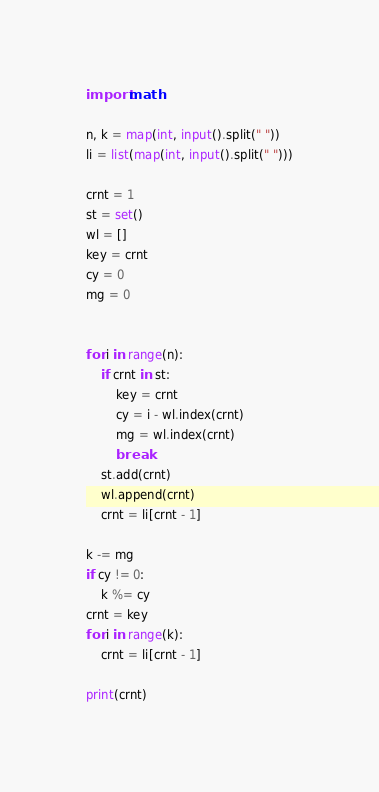Convert code to text. <code><loc_0><loc_0><loc_500><loc_500><_Python_>import math

n, k = map(int, input().split(" "))
li = list(map(int, input().split(" ")))

crnt = 1
st = set()
wl = []
key = crnt
cy = 0
mg = 0


for i in range(n):
    if crnt in st:
        key = crnt
        cy = i - wl.index(crnt)
        mg = wl.index(crnt)
        break
    st.add(crnt)
    wl.append(crnt)
    crnt = li[crnt - 1]

k -= mg
if cy != 0:
    k %= cy
crnt = key
for i in range(k):
    crnt = li[crnt - 1]

print(crnt)
</code> 